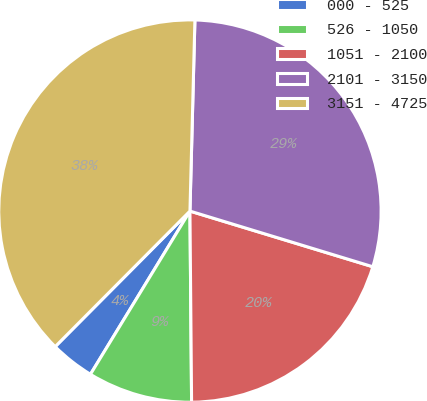Convert chart. <chart><loc_0><loc_0><loc_500><loc_500><pie_chart><fcel>000 - 525<fcel>526 - 1050<fcel>1051 - 2100<fcel>2101 - 3150<fcel>3151 - 4725<nl><fcel>3.74%<fcel>8.85%<fcel>20.16%<fcel>29.29%<fcel>37.96%<nl></chart> 